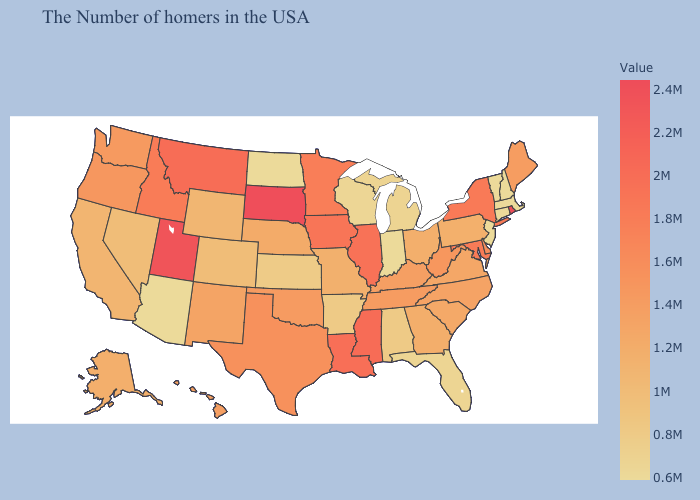Which states have the lowest value in the USA?
Write a very short answer. Massachusetts, New Hampshire, Vermont, Connecticut, New Jersey, Indiana, North Dakota, Arizona. Does Hawaii have a higher value than Illinois?
Write a very short answer. No. Is the legend a continuous bar?
Short answer required. Yes. Which states hav the highest value in the MidWest?
Quick response, please. South Dakota. Which states hav the highest value in the West?
Quick response, please. Utah. Which states have the lowest value in the South?
Concise answer only. Florida. Does South Dakota have the highest value in the MidWest?
Quick response, please. Yes. Among the states that border Wyoming , which have the lowest value?
Short answer required. Colorado. 